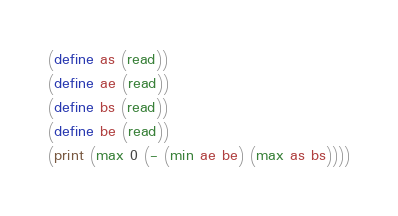<code> <loc_0><loc_0><loc_500><loc_500><_Scheme_>(define as (read))
(define ae (read))
(define bs (read))
(define be (read))
(print (max 0 (- (min ae be) (max as bs))))</code> 